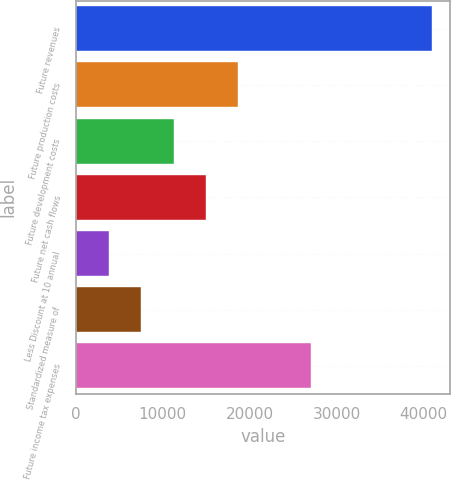<chart> <loc_0><loc_0><loc_500><loc_500><bar_chart><fcel>Future revenues<fcel>Future production costs<fcel>Future development costs<fcel>Future net cash flows<fcel>Less Discount at 10 annual<fcel>Standardized measure of<fcel>Future income tax expenses<nl><fcel>41010<fcel>18697.2<fcel>11259.6<fcel>14978.4<fcel>3822<fcel>7540.8<fcel>27060<nl></chart> 